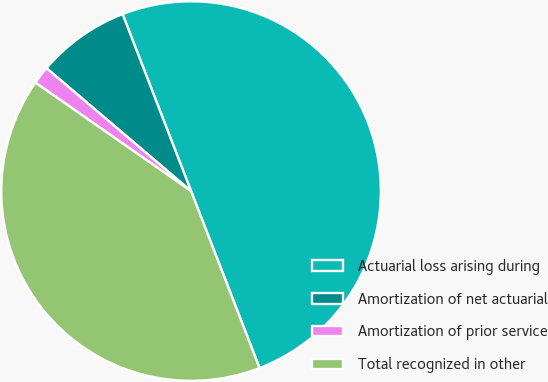Convert chart to OTSL. <chart><loc_0><loc_0><loc_500><loc_500><pie_chart><fcel>Actuarial loss arising during<fcel>Amortization of net actuarial<fcel>Amortization of prior service<fcel>Total recognized in other<nl><fcel>50.0%<fcel>7.91%<fcel>1.53%<fcel>40.56%<nl></chart> 